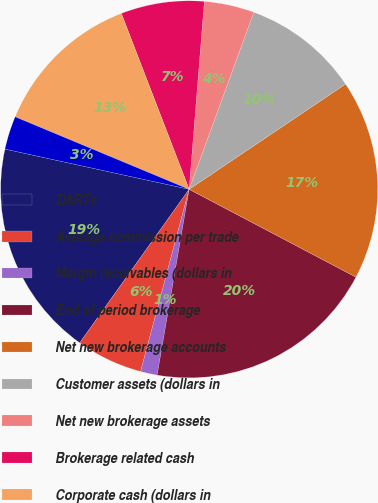Convert chart to OTSL. <chart><loc_0><loc_0><loc_500><loc_500><pie_chart><fcel>DARTs<fcel>Average commission per trade<fcel>Margin receivables (dollars in<fcel>End of period brokerage<fcel>Net new brokerage accounts<fcel>Customer assets (dollars in<fcel>Net new brokerage assets<fcel>Brokerage related cash<fcel>Corporate cash (dollars in<fcel>ETRADE Bank Tier 1 leverage<nl><fcel>18.57%<fcel>5.71%<fcel>1.43%<fcel>20.0%<fcel>17.14%<fcel>10.0%<fcel>4.29%<fcel>7.14%<fcel>12.86%<fcel>2.86%<nl></chart> 